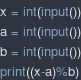<code> <loc_0><loc_0><loc_500><loc_500><_Python_>x = int(input())
a = int(input())
b = int(input())
print((x-a)%b)
</code> 